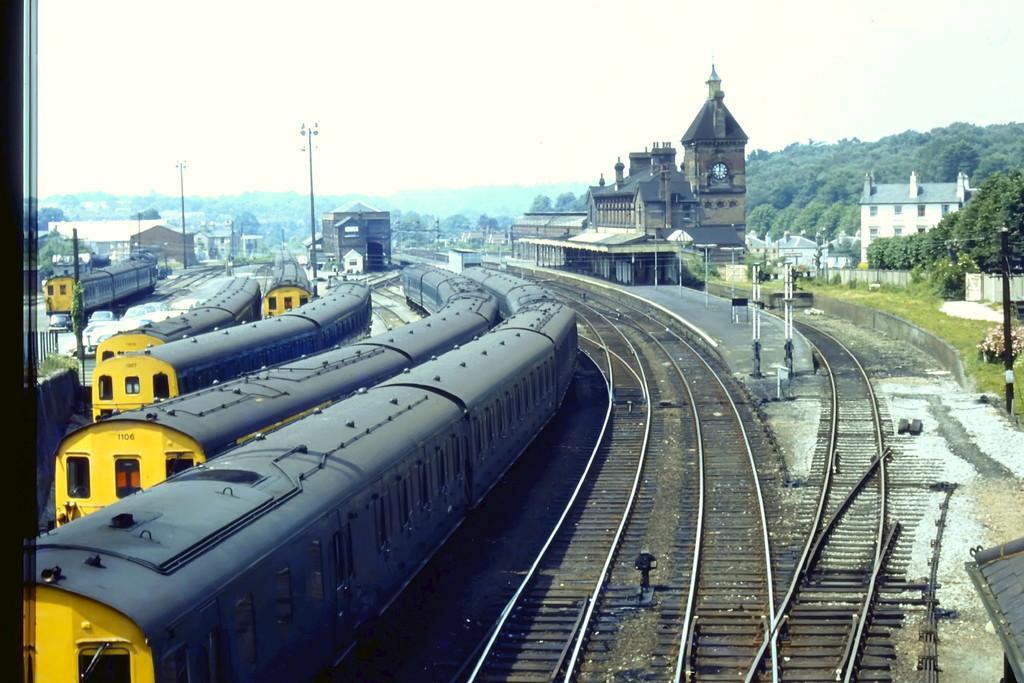Describe this image in one or two sentences. In the center of the image, we can see trains and tracks and in the background, there are poles, buildings, and trees. 